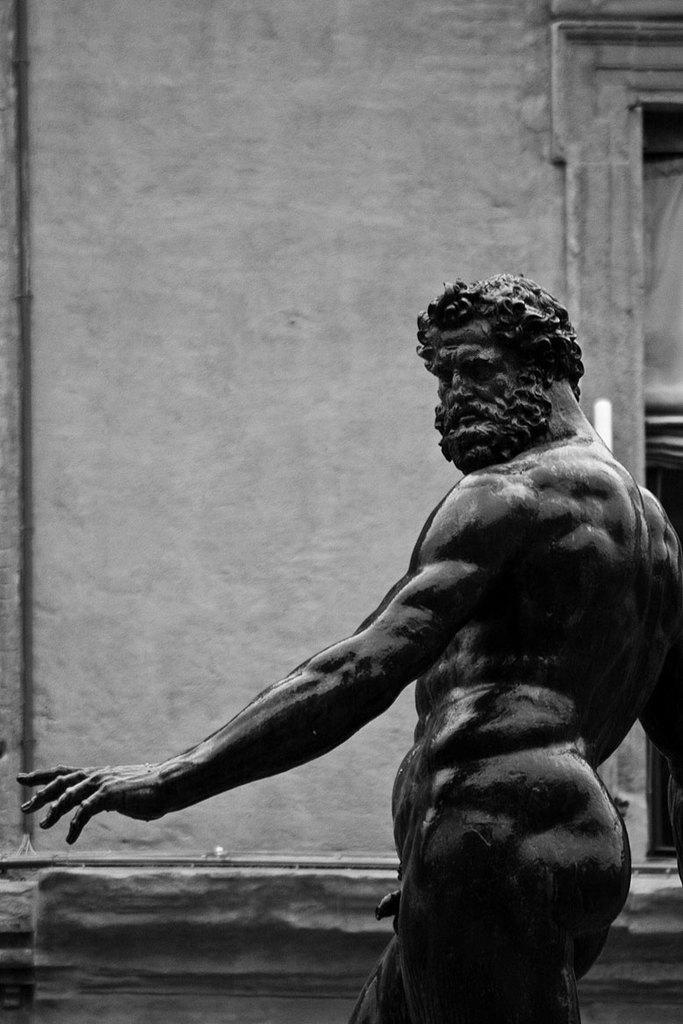Could you give a brief overview of what you see in this image? This is a black and white picture, there is a man statue on the left side and behind it there is a wall. 